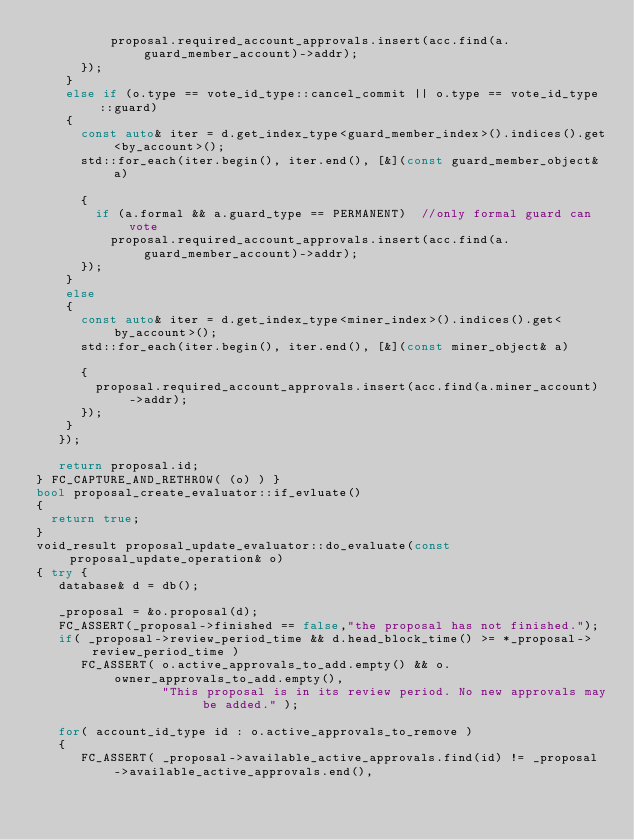Convert code to text. <code><loc_0><loc_0><loc_500><loc_500><_C++_>				  proposal.required_account_approvals.insert(acc.find(a.guard_member_account)->addr);
		  });
	  }
	  else if (o.type == vote_id_type::cancel_commit || o.type == vote_id_type::guard)
	  {
		  const auto& iter = d.get_index_type<guard_member_index>().indices().get<by_account>();
		  std::for_each(iter.begin(), iter.end(), [&](const guard_member_object& a)

		  {
			  if (a.formal && a.guard_type == PERMANENT)  //only formal guard can vote
				  proposal.required_account_approvals.insert(acc.find(a.guard_member_account)->addr);
		  });
	  }
	  else
	  {
		  const auto& iter = d.get_index_type<miner_index>().indices().get<by_account>();
		  std::for_each(iter.begin(), iter.end(), [&](const miner_object& a)

		  {
			  proposal.required_account_approvals.insert(acc.find(a.miner_account)->addr);
		  });
	  }
   });

   return proposal.id;
} FC_CAPTURE_AND_RETHROW( (o) ) }
bool proposal_create_evaluator::if_evluate()
{
	return true;
}
void_result proposal_update_evaluator::do_evaluate(const proposal_update_operation& o)
{ try {
   database& d = db();

   _proposal = &o.proposal(d);
   FC_ASSERT(_proposal->finished == false,"the proposal has not finished.");
   if( _proposal->review_period_time && d.head_block_time() >= *_proposal->review_period_time )
      FC_ASSERT( o.active_approvals_to_add.empty() && o.owner_approvals_to_add.empty(),
                 "This proposal is in its review period. No new approvals may be added." );

   for( account_id_type id : o.active_approvals_to_remove )
   {
      FC_ASSERT( _proposal->available_active_approvals.find(id) != _proposal->available_active_approvals.end(),</code> 